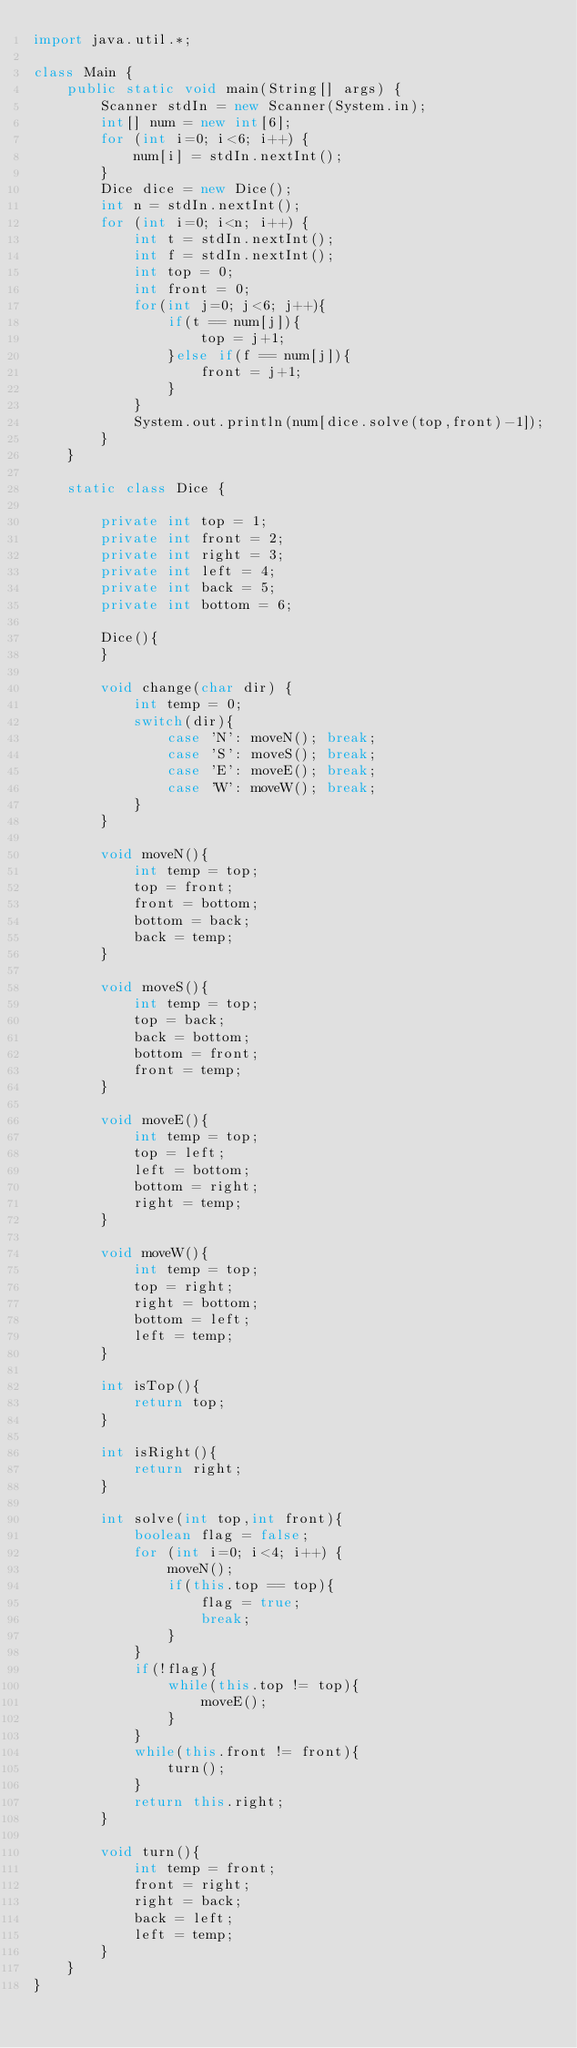Convert code to text. <code><loc_0><loc_0><loc_500><loc_500><_Java_>import java.util.*;

class Main {
	public static void main(String[] args) {
		Scanner stdIn = new Scanner(System.in);
		int[] num = new int[6];
		for (int i=0; i<6; i++) {
			num[i] = stdIn.nextInt();
		}
		Dice dice = new Dice();
		int n = stdIn.nextInt();
		for (int i=0; i<n; i++) {
			int t = stdIn.nextInt();
			int f = stdIn.nextInt();
			int top = 0;
			int front = 0;
			for(int j=0; j<6; j++){
				if(t == num[j]){
					top = j+1;
				}else if(f == num[j]){
					front = j+1;
				}
			}
			System.out.println(num[dice.solve(top,front)-1]);
		}
	}

	static class Dice {

		private int top = 1;
		private int front = 2;
		private int right = 3;
		private int left = 4;
		private int back = 5;
		private int bottom = 6;

		Dice(){
		}

		void change(char dir) {
			int temp = 0;
			switch(dir){
				case 'N': moveN(); break;
				case 'S': moveS(); break;
				case 'E': moveE(); break;
				case 'W': moveW(); break;
			}
		}

		void moveN(){
			int temp = top;
			top = front;
			front = bottom;
			bottom = back;
			back = temp;
		}

		void moveS(){
			int temp = top;
			top = back;
			back = bottom;
			bottom = front;
			front = temp;
		}

		void moveE(){
			int temp = top;
			top = left;
			left = bottom;
			bottom = right;
			right = temp;
		}

		void moveW(){
			int temp = top;
			top = right;
			right = bottom;
			bottom = left;
			left = temp;
		}

		int isTop(){
			return top;
		}

		int isRight(){
			return right;
		}

		int solve(int top,int front){
			boolean flag = false;
			for (int i=0; i<4; i++) {
				moveN();
				if(this.top == top){
					flag = true;
					break;
				}
			}
			if(!flag){
				while(this.top != top){
					moveE();
				}
			}
			while(this.front != front){
				turn();
			}
			return this.right;
		}

		void turn(){
			int temp = front;
			front = right;
			right = back;
			back = left;
			left = temp;
		}
	}
}</code> 